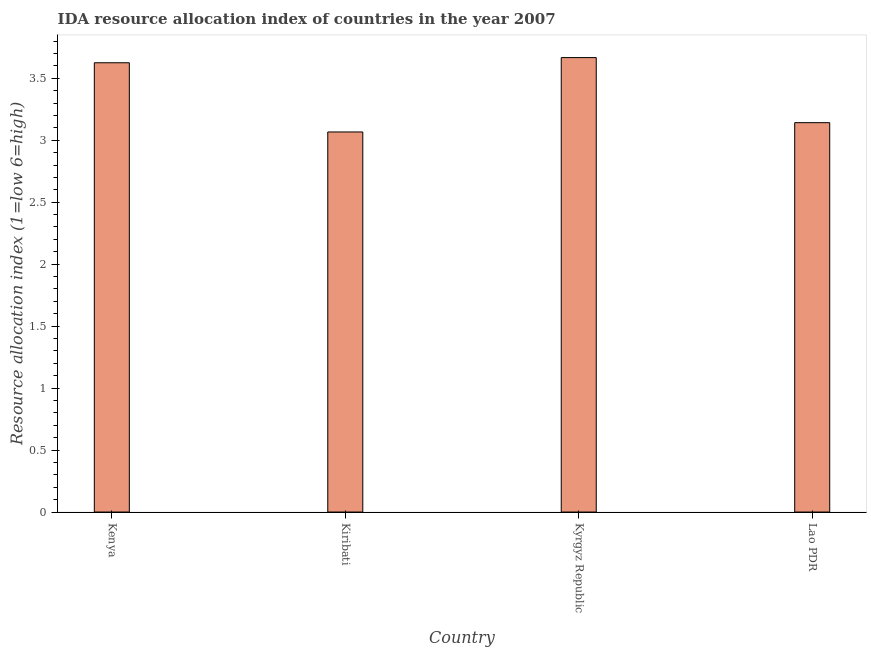Does the graph contain any zero values?
Provide a succinct answer. No. Does the graph contain grids?
Your response must be concise. No. What is the title of the graph?
Keep it short and to the point. IDA resource allocation index of countries in the year 2007. What is the label or title of the X-axis?
Offer a very short reply. Country. What is the label or title of the Y-axis?
Keep it short and to the point. Resource allocation index (1=low 6=high). What is the ida resource allocation index in Lao PDR?
Provide a succinct answer. 3.14. Across all countries, what is the maximum ida resource allocation index?
Make the answer very short. 3.67. Across all countries, what is the minimum ida resource allocation index?
Ensure brevity in your answer.  3.07. In which country was the ida resource allocation index maximum?
Provide a short and direct response. Kyrgyz Republic. In which country was the ida resource allocation index minimum?
Keep it short and to the point. Kiribati. What is the sum of the ida resource allocation index?
Give a very brief answer. 13.5. What is the average ida resource allocation index per country?
Offer a terse response. 3.38. What is the median ida resource allocation index?
Keep it short and to the point. 3.38. What is the ratio of the ida resource allocation index in Kiribati to that in Kyrgyz Republic?
Your answer should be compact. 0.84. Is the ida resource allocation index in Kenya less than that in Kiribati?
Provide a succinct answer. No. What is the difference between the highest and the second highest ida resource allocation index?
Provide a short and direct response. 0.04. What is the difference between the highest and the lowest ida resource allocation index?
Offer a very short reply. 0.6. What is the difference between two consecutive major ticks on the Y-axis?
Keep it short and to the point. 0.5. Are the values on the major ticks of Y-axis written in scientific E-notation?
Make the answer very short. No. What is the Resource allocation index (1=low 6=high) of Kenya?
Your answer should be compact. 3.62. What is the Resource allocation index (1=low 6=high) in Kiribati?
Offer a very short reply. 3.07. What is the Resource allocation index (1=low 6=high) in Kyrgyz Republic?
Provide a short and direct response. 3.67. What is the Resource allocation index (1=low 6=high) in Lao PDR?
Ensure brevity in your answer.  3.14. What is the difference between the Resource allocation index (1=low 6=high) in Kenya and Kiribati?
Provide a succinct answer. 0.56. What is the difference between the Resource allocation index (1=low 6=high) in Kenya and Kyrgyz Republic?
Provide a succinct answer. -0.04. What is the difference between the Resource allocation index (1=low 6=high) in Kenya and Lao PDR?
Give a very brief answer. 0.48. What is the difference between the Resource allocation index (1=low 6=high) in Kiribati and Lao PDR?
Your answer should be compact. -0.07. What is the difference between the Resource allocation index (1=low 6=high) in Kyrgyz Republic and Lao PDR?
Give a very brief answer. 0.53. What is the ratio of the Resource allocation index (1=low 6=high) in Kenya to that in Kiribati?
Your answer should be compact. 1.18. What is the ratio of the Resource allocation index (1=low 6=high) in Kenya to that in Kyrgyz Republic?
Your response must be concise. 0.99. What is the ratio of the Resource allocation index (1=low 6=high) in Kenya to that in Lao PDR?
Your response must be concise. 1.15. What is the ratio of the Resource allocation index (1=low 6=high) in Kiribati to that in Kyrgyz Republic?
Your answer should be compact. 0.84. What is the ratio of the Resource allocation index (1=low 6=high) in Kiribati to that in Lao PDR?
Offer a very short reply. 0.98. What is the ratio of the Resource allocation index (1=low 6=high) in Kyrgyz Republic to that in Lao PDR?
Your response must be concise. 1.17. 